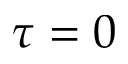Convert formula to latex. <formula><loc_0><loc_0><loc_500><loc_500>\tau = 0</formula> 